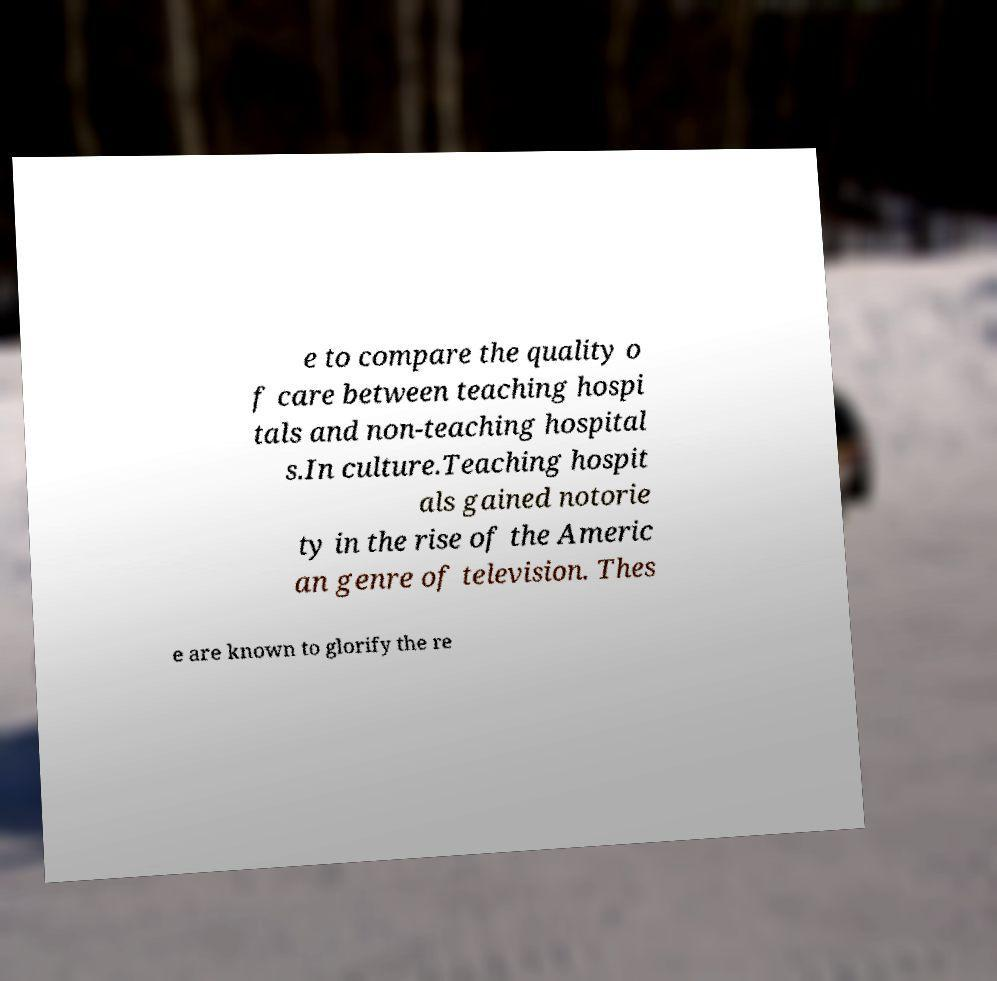Please read and relay the text visible in this image. What does it say? e to compare the quality o f care between teaching hospi tals and non-teaching hospital s.In culture.Teaching hospit als gained notorie ty in the rise of the Americ an genre of television. Thes e are known to glorify the re 